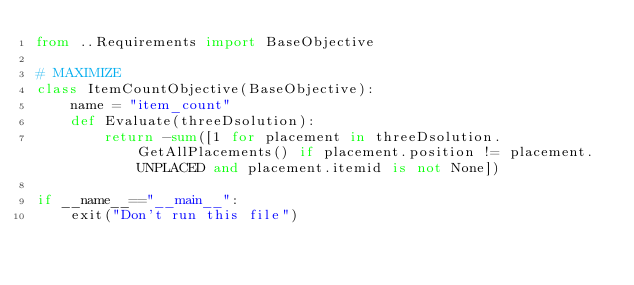Convert code to text. <code><loc_0><loc_0><loc_500><loc_500><_Python_>from ..Requirements import BaseObjective

# MAXIMIZE
class ItemCountObjective(BaseObjective):
    name = "item_count"
    def Evaluate(threeDsolution):
        return -sum([1 for placement in threeDsolution.GetAllPlacements() if placement.position != placement.UNPLACED and placement.itemid is not None])

if __name__=="__main__":
    exit("Don't run this file")</code> 